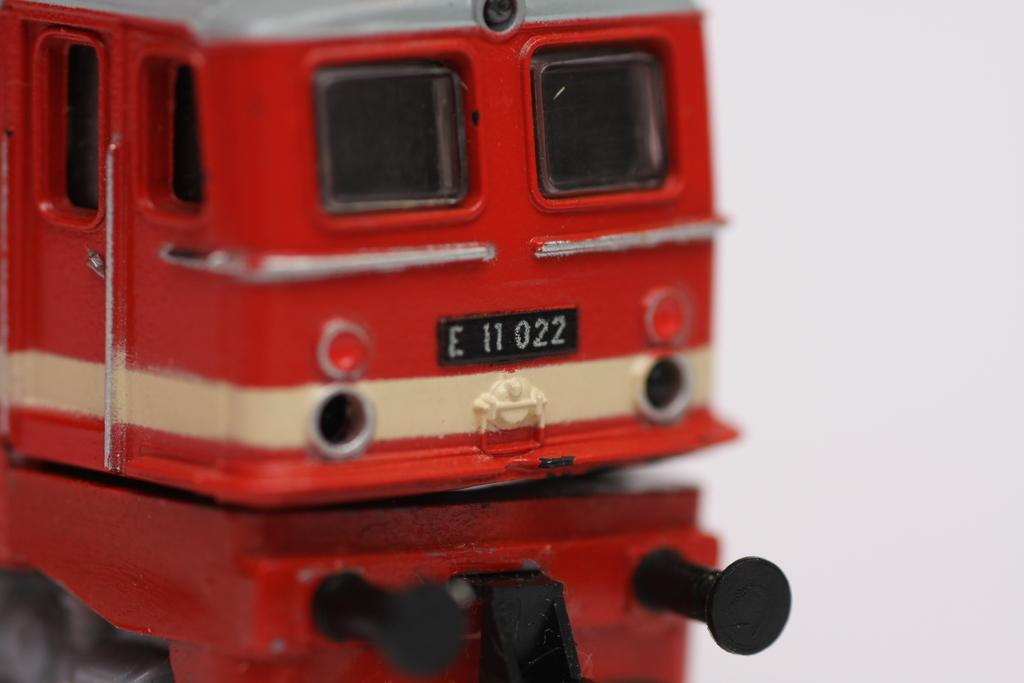<image>
Describe the image concisely. A toy train car in red and white with a liscense tag reading E 11 022. 